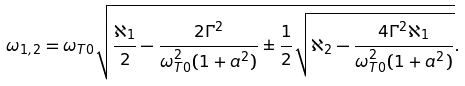<formula> <loc_0><loc_0><loc_500><loc_500>\omega _ { 1 , 2 } = \omega _ { T 0 } \sqrt { \frac { \aleph _ { 1 } } { 2 } - \frac { 2 \Gamma ^ { 2 } } { \omega _ { T 0 } ^ { 2 } ( 1 + a ^ { 2 } ) } \pm \frac { 1 } { 2 } \sqrt { \aleph _ { 2 } - \frac { 4 \Gamma ^ { 2 } \aleph _ { 1 } } { \omega _ { T 0 } ^ { 2 } ( 1 + a ^ { 2 } ) } } } .</formula> 